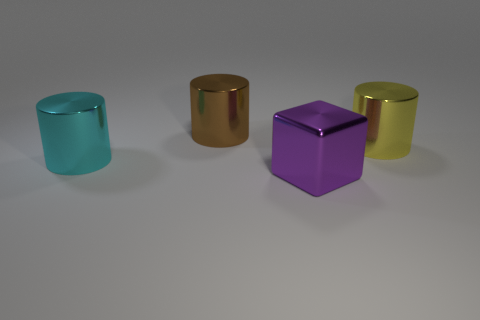Add 3 yellow shiny cylinders. How many objects exist? 7 Subtract all cylinders. How many objects are left? 1 Add 3 large cyan shiny cylinders. How many large cyan shiny cylinders exist? 4 Subtract 1 cyan cylinders. How many objects are left? 3 Subtract all blue metallic cylinders. Subtract all yellow shiny cylinders. How many objects are left? 3 Add 4 purple cubes. How many purple cubes are left? 5 